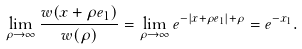<formula> <loc_0><loc_0><loc_500><loc_500>\lim _ { \rho \rightarrow \infty } \frac { w ( x + \rho { e } _ { 1 } ) } { w ( \rho ) } = \lim _ { \rho \to \infty } e ^ { - | x + \rho { e } _ { 1 } | + \rho } = e ^ { - x _ { 1 } } .</formula> 